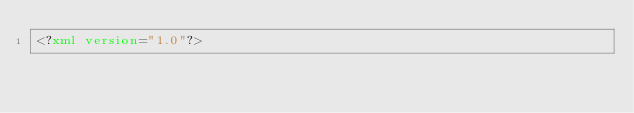Convert code to text. <code><loc_0><loc_0><loc_500><loc_500><_XML_><?xml version="1.0"?></code> 